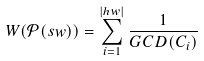<formula> <loc_0><loc_0><loc_500><loc_500>W ( \mathcal { P } ( s w ) ) = \sum _ { i = 1 } ^ { | h w | } \frac { 1 } { G C D ( C _ { i } ) }</formula> 